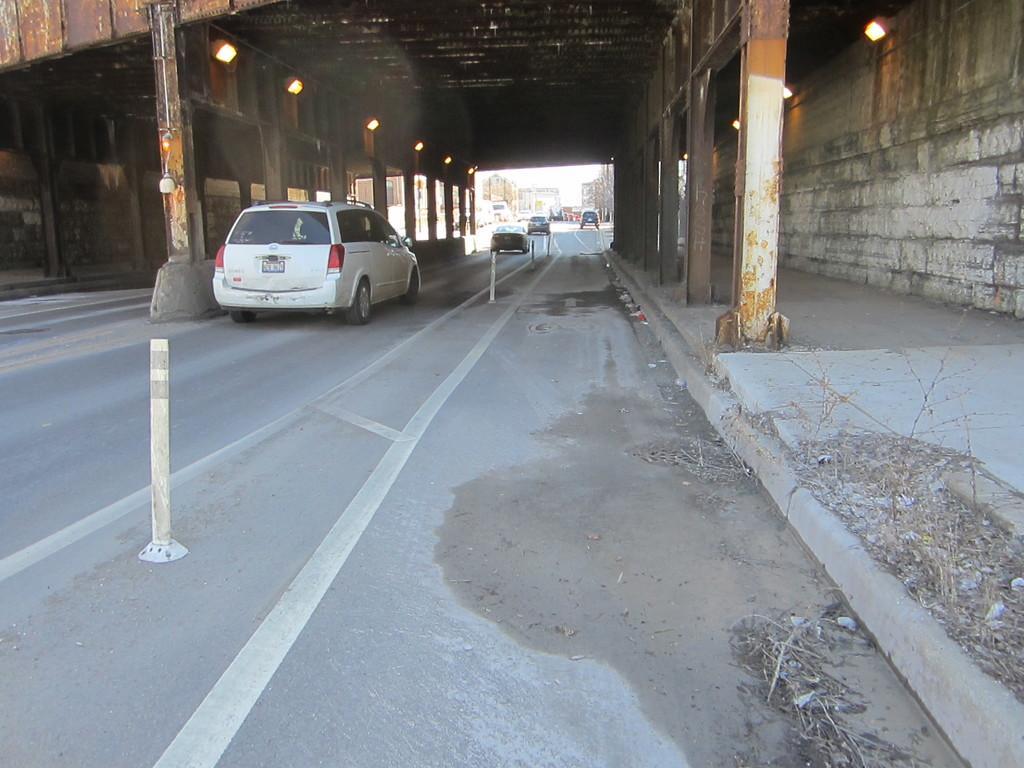In one or two sentences, can you explain what this image depicts? In this picture we can see few vehicles on the road and we can find few poles on the road, and also we can see a metal bridge over the road and few lights, in the background we can see few buildings and trees. 